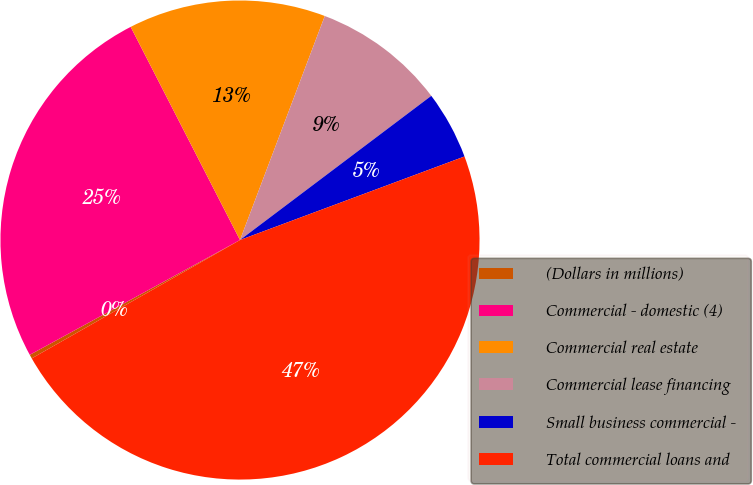<chart> <loc_0><loc_0><loc_500><loc_500><pie_chart><fcel>(Dollars in millions)<fcel>Commercial - domestic (4)<fcel>Commercial real estate<fcel>Commercial lease financing<fcel>Small business commercial -<fcel>Total commercial loans and<nl><fcel>0.27%<fcel>25.41%<fcel>13.3%<fcel>8.96%<fcel>4.61%<fcel>47.44%<nl></chart> 